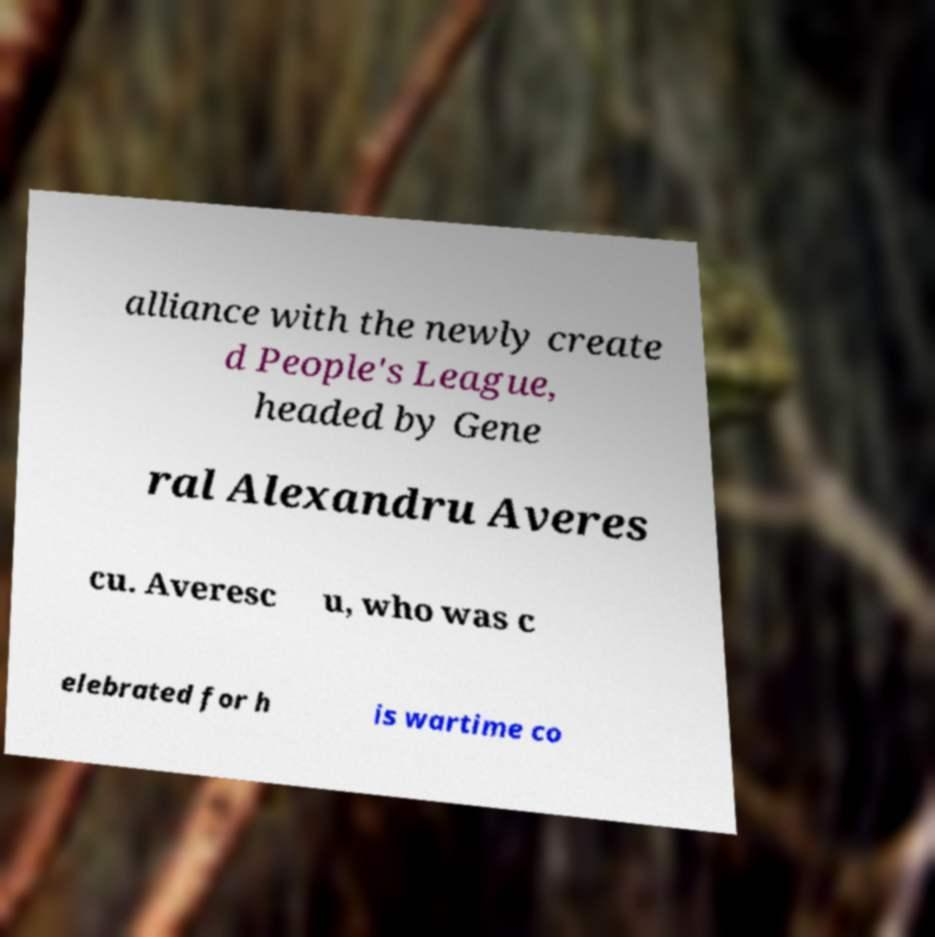Please identify and transcribe the text found in this image. alliance with the newly create d People's League, headed by Gene ral Alexandru Averes cu. Averesc u, who was c elebrated for h is wartime co 